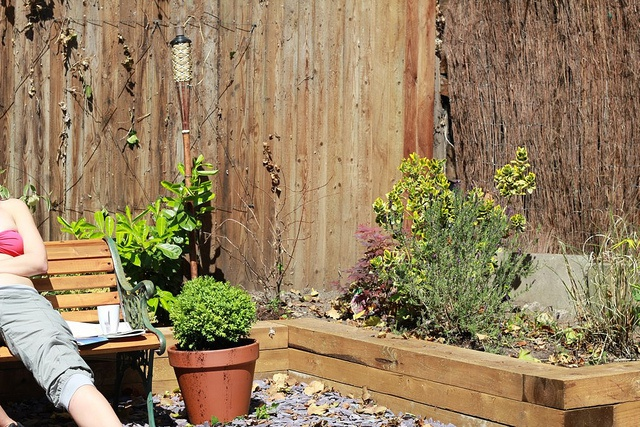Describe the objects in this image and their specific colors. I can see people in gray, lightgray, darkgray, lightpink, and tan tones, potted plant in gray, black, brown, salmon, and red tones, bench in gray, tan, black, and maroon tones, book in gray, white, black, and darkgray tones, and cup in gray, white, darkgray, and lightgray tones in this image. 